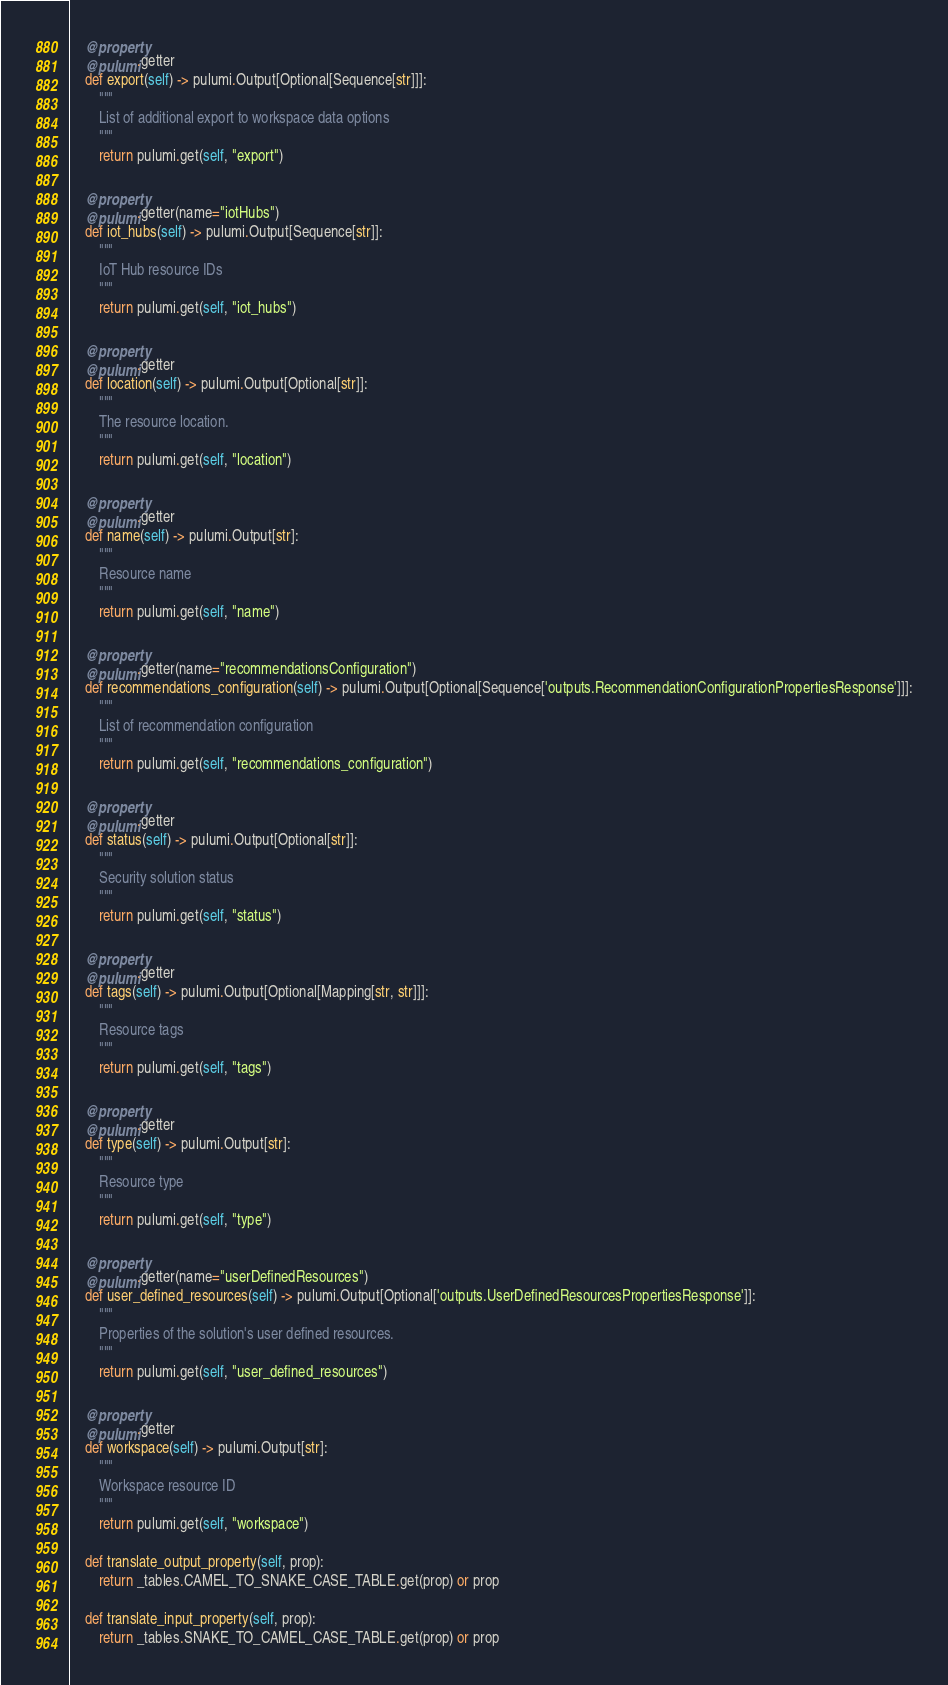Convert code to text. <code><loc_0><loc_0><loc_500><loc_500><_Python_>    @property
    @pulumi.getter
    def export(self) -> pulumi.Output[Optional[Sequence[str]]]:
        """
        List of additional export to workspace data options
        """
        return pulumi.get(self, "export")

    @property
    @pulumi.getter(name="iotHubs")
    def iot_hubs(self) -> pulumi.Output[Sequence[str]]:
        """
        IoT Hub resource IDs
        """
        return pulumi.get(self, "iot_hubs")

    @property
    @pulumi.getter
    def location(self) -> pulumi.Output[Optional[str]]:
        """
        The resource location.
        """
        return pulumi.get(self, "location")

    @property
    @pulumi.getter
    def name(self) -> pulumi.Output[str]:
        """
        Resource name
        """
        return pulumi.get(self, "name")

    @property
    @pulumi.getter(name="recommendationsConfiguration")
    def recommendations_configuration(self) -> pulumi.Output[Optional[Sequence['outputs.RecommendationConfigurationPropertiesResponse']]]:
        """
        List of recommendation configuration
        """
        return pulumi.get(self, "recommendations_configuration")

    @property
    @pulumi.getter
    def status(self) -> pulumi.Output[Optional[str]]:
        """
        Security solution status
        """
        return pulumi.get(self, "status")

    @property
    @pulumi.getter
    def tags(self) -> pulumi.Output[Optional[Mapping[str, str]]]:
        """
        Resource tags
        """
        return pulumi.get(self, "tags")

    @property
    @pulumi.getter
    def type(self) -> pulumi.Output[str]:
        """
        Resource type
        """
        return pulumi.get(self, "type")

    @property
    @pulumi.getter(name="userDefinedResources")
    def user_defined_resources(self) -> pulumi.Output[Optional['outputs.UserDefinedResourcesPropertiesResponse']]:
        """
        Properties of the solution's user defined resources.
        """
        return pulumi.get(self, "user_defined_resources")

    @property
    @pulumi.getter
    def workspace(self) -> pulumi.Output[str]:
        """
        Workspace resource ID
        """
        return pulumi.get(self, "workspace")

    def translate_output_property(self, prop):
        return _tables.CAMEL_TO_SNAKE_CASE_TABLE.get(prop) or prop

    def translate_input_property(self, prop):
        return _tables.SNAKE_TO_CAMEL_CASE_TABLE.get(prop) or prop

</code> 